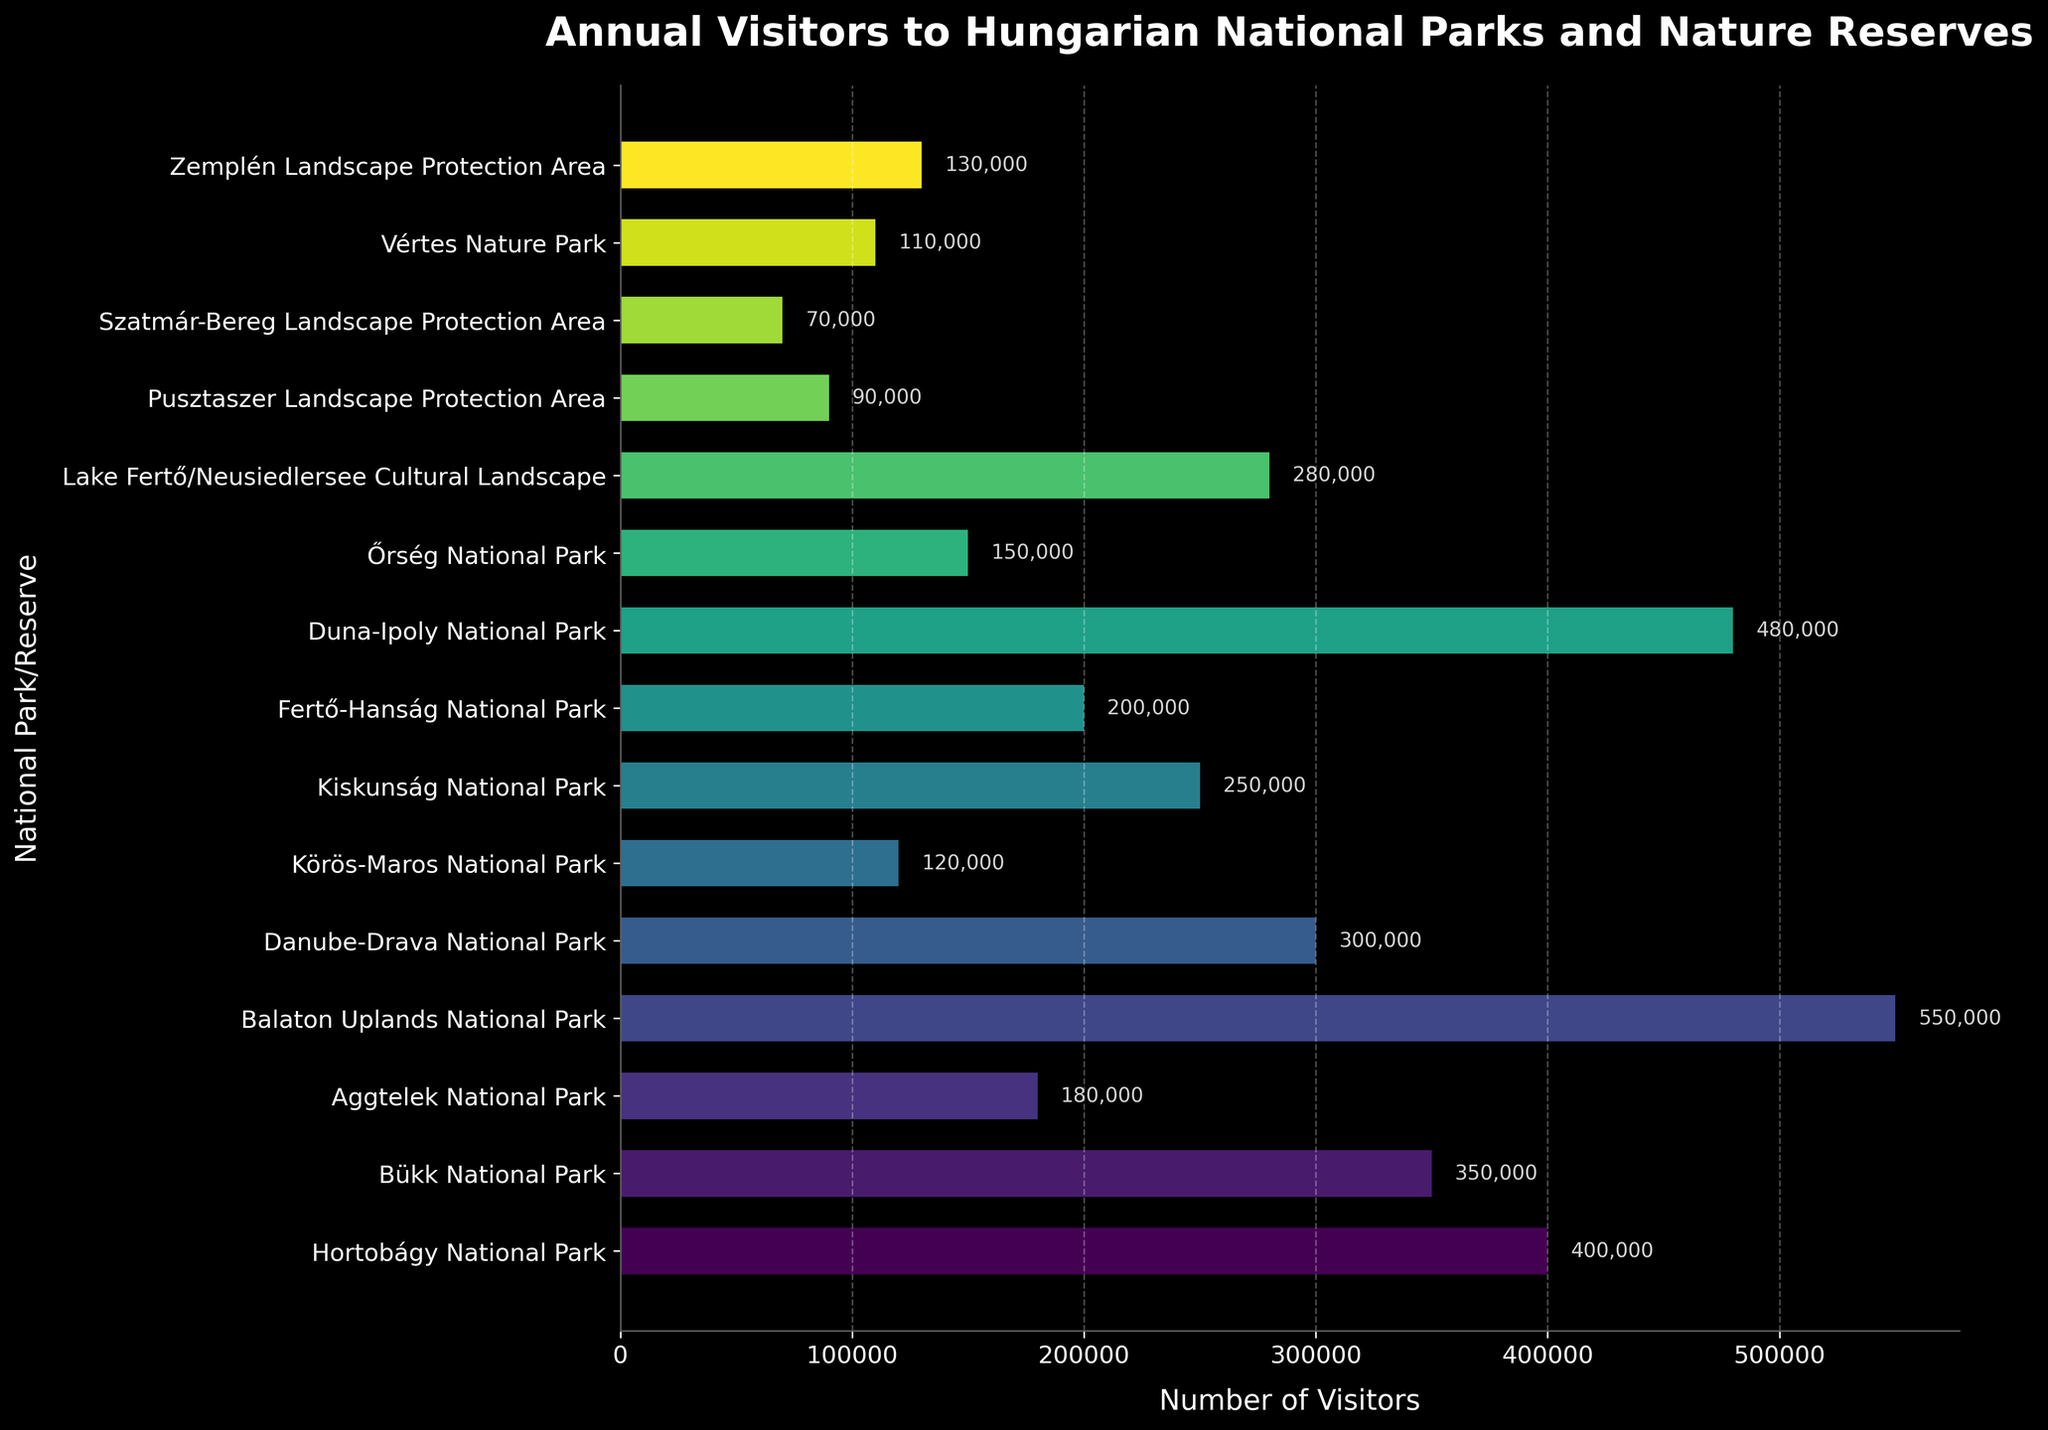Which park has the highest number of annual visitors? Look at the bar lengths and the labels; the highest bar represents Balaton Uplands National Park.
Answer: Balaton Uplands National Park How many more visitors does Duna-Ipoly National Park have compared to Aggtelek National Park? Find the visitor numbers for both parks and subtract Aggtelek’s from Duna-Ipoly’s: 480,000 - 180,000 = 300,000.
Answer: 300,000 What is the combined number of visitors for Hortobágy National Park, Bükk National Park, and Danube-Drava National Park? Add the number of visitors for these parks: 400,000 + 350,000 + 300,000 = 1,050,000.
Answer: 1,050,000 Which park has the fewest visitors, and how many visitors does it have? Identify the park with the shortest bar; Pusztaszer Landscape Protection Area has the fewest visitors with 90,000.
Answer: Pusztaszer Landscape Protection Area, 90,000 What is the average number of annual visitors across all parks and reserves? Sum up all the visitors and divide by the number of parks/reserves: (400000 + 350000 + 180000 + 550000 + 300000 + 120000 + 250000 + 200000 + 480000 + 150000 + 280000 + 90000 + 70000 + 110000 + 130000) / 15 = 259,333.33.
Answer: 259,333.33 Compare the number of visitors between Kiskunság National Park and Fertő-Hanság National Park. Which one has more, and by how much? Compare the numbers: Kiskunság has 250,000 visitors, Fertő-Hanság has 200,000. Find the difference: 250,000 - 200,000 = 50,000.
Answer: Kiskunság National Park, by 50,000 Which parks have more than 300,000 visitors annually? Identify bars longer than 300,000 visitors: Hortobágy, Bükk, Balaton Uplands, Duna-Ipoly.
Answer: Hortobágy National Park, Bükk National Park, Balaton Uplands National Park, Duna-Ipoly National Park What is the median number of visitors among all parks and reserves? Arrange the visitor numbers in ascending order and find the middle value: (70,000, 90,000, 110,000, 120,000, 130,000, 150,000, 180,000, 200,000, 250,000, 280,000, 300,000, 350,000, 400,000, 480,000, 550,000) → Median is the 8th value (200,000).
Answer: 200,000 